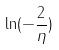Convert formula to latex. <formula><loc_0><loc_0><loc_500><loc_500>\ln ( - \frac { 2 } { \eta } )</formula> 